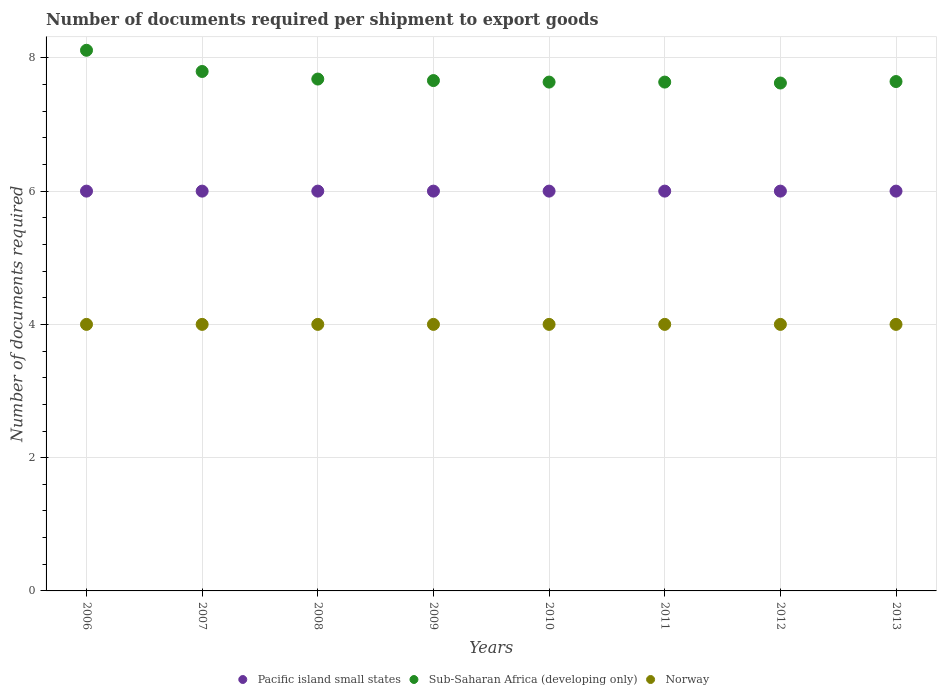How many different coloured dotlines are there?
Give a very brief answer. 3. What is the number of documents required per shipment to export goods in Norway in 2009?
Provide a short and direct response. 4. Across all years, what is the maximum number of documents required per shipment to export goods in Pacific island small states?
Provide a short and direct response. 6. In which year was the number of documents required per shipment to export goods in Sub-Saharan Africa (developing only) maximum?
Make the answer very short. 2006. In which year was the number of documents required per shipment to export goods in Sub-Saharan Africa (developing only) minimum?
Ensure brevity in your answer.  2012. What is the total number of documents required per shipment to export goods in Norway in the graph?
Offer a very short reply. 32. What is the difference between the number of documents required per shipment to export goods in Sub-Saharan Africa (developing only) in 2009 and the number of documents required per shipment to export goods in Pacific island small states in 2012?
Your answer should be very brief. 1.66. What is the average number of documents required per shipment to export goods in Sub-Saharan Africa (developing only) per year?
Give a very brief answer. 7.72. In the year 2008, what is the difference between the number of documents required per shipment to export goods in Pacific island small states and number of documents required per shipment to export goods in Sub-Saharan Africa (developing only)?
Provide a short and direct response. -1.68. In how many years, is the number of documents required per shipment to export goods in Pacific island small states greater than 6?
Give a very brief answer. 0. What is the difference between the highest and the lowest number of documents required per shipment to export goods in Sub-Saharan Africa (developing only)?
Your response must be concise. 0.49. In how many years, is the number of documents required per shipment to export goods in Pacific island small states greater than the average number of documents required per shipment to export goods in Pacific island small states taken over all years?
Keep it short and to the point. 0. Is the sum of the number of documents required per shipment to export goods in Sub-Saharan Africa (developing only) in 2011 and 2013 greater than the maximum number of documents required per shipment to export goods in Pacific island small states across all years?
Keep it short and to the point. Yes. Is the number of documents required per shipment to export goods in Sub-Saharan Africa (developing only) strictly greater than the number of documents required per shipment to export goods in Norway over the years?
Your response must be concise. Yes. How many years are there in the graph?
Keep it short and to the point. 8. Does the graph contain any zero values?
Your answer should be very brief. No. Does the graph contain grids?
Offer a very short reply. Yes. Where does the legend appear in the graph?
Offer a terse response. Bottom center. How many legend labels are there?
Provide a short and direct response. 3. What is the title of the graph?
Your answer should be very brief. Number of documents required per shipment to export goods. Does "Europe(developing only)" appear as one of the legend labels in the graph?
Provide a short and direct response. No. What is the label or title of the X-axis?
Offer a very short reply. Years. What is the label or title of the Y-axis?
Your answer should be very brief. Number of documents required. What is the Number of documents required in Pacific island small states in 2006?
Provide a succinct answer. 6. What is the Number of documents required of Sub-Saharan Africa (developing only) in 2006?
Make the answer very short. 8.11. What is the Number of documents required in Norway in 2006?
Offer a terse response. 4. What is the Number of documents required of Sub-Saharan Africa (developing only) in 2007?
Provide a succinct answer. 7.8. What is the Number of documents required in Norway in 2007?
Make the answer very short. 4. What is the Number of documents required in Pacific island small states in 2008?
Keep it short and to the point. 6. What is the Number of documents required of Sub-Saharan Africa (developing only) in 2008?
Give a very brief answer. 7.68. What is the Number of documents required in Pacific island small states in 2009?
Provide a succinct answer. 6. What is the Number of documents required of Sub-Saharan Africa (developing only) in 2009?
Your answer should be very brief. 7.66. What is the Number of documents required in Norway in 2009?
Your answer should be compact. 4. What is the Number of documents required in Sub-Saharan Africa (developing only) in 2010?
Make the answer very short. 7.64. What is the Number of documents required in Norway in 2010?
Make the answer very short. 4. What is the Number of documents required of Pacific island small states in 2011?
Your answer should be compact. 6. What is the Number of documents required of Sub-Saharan Africa (developing only) in 2011?
Give a very brief answer. 7.64. What is the Number of documents required of Sub-Saharan Africa (developing only) in 2012?
Offer a very short reply. 7.62. What is the Number of documents required in Norway in 2012?
Offer a terse response. 4. What is the Number of documents required of Pacific island small states in 2013?
Keep it short and to the point. 6. What is the Number of documents required of Sub-Saharan Africa (developing only) in 2013?
Provide a succinct answer. 7.64. What is the Number of documents required in Norway in 2013?
Your answer should be very brief. 4. Across all years, what is the maximum Number of documents required in Pacific island small states?
Offer a very short reply. 6. Across all years, what is the maximum Number of documents required in Sub-Saharan Africa (developing only)?
Offer a terse response. 8.11. Across all years, what is the maximum Number of documents required of Norway?
Give a very brief answer. 4. Across all years, what is the minimum Number of documents required of Pacific island small states?
Your answer should be very brief. 6. Across all years, what is the minimum Number of documents required of Sub-Saharan Africa (developing only)?
Offer a very short reply. 7.62. Across all years, what is the minimum Number of documents required of Norway?
Provide a short and direct response. 4. What is the total Number of documents required of Pacific island small states in the graph?
Keep it short and to the point. 48. What is the total Number of documents required of Sub-Saharan Africa (developing only) in the graph?
Provide a short and direct response. 61.79. What is the total Number of documents required of Norway in the graph?
Give a very brief answer. 32. What is the difference between the Number of documents required in Sub-Saharan Africa (developing only) in 2006 and that in 2007?
Your answer should be very brief. 0.32. What is the difference between the Number of documents required in Sub-Saharan Africa (developing only) in 2006 and that in 2008?
Ensure brevity in your answer.  0.43. What is the difference between the Number of documents required in Norway in 2006 and that in 2008?
Keep it short and to the point. 0. What is the difference between the Number of documents required of Sub-Saharan Africa (developing only) in 2006 and that in 2009?
Your answer should be very brief. 0.45. What is the difference between the Number of documents required in Norway in 2006 and that in 2009?
Offer a very short reply. 0. What is the difference between the Number of documents required in Sub-Saharan Africa (developing only) in 2006 and that in 2010?
Ensure brevity in your answer.  0.48. What is the difference between the Number of documents required in Sub-Saharan Africa (developing only) in 2006 and that in 2011?
Offer a terse response. 0.48. What is the difference between the Number of documents required of Norway in 2006 and that in 2011?
Keep it short and to the point. 0. What is the difference between the Number of documents required of Sub-Saharan Africa (developing only) in 2006 and that in 2012?
Give a very brief answer. 0.49. What is the difference between the Number of documents required of Norway in 2006 and that in 2012?
Provide a short and direct response. 0. What is the difference between the Number of documents required of Sub-Saharan Africa (developing only) in 2006 and that in 2013?
Keep it short and to the point. 0.47. What is the difference between the Number of documents required of Norway in 2006 and that in 2013?
Ensure brevity in your answer.  0. What is the difference between the Number of documents required of Pacific island small states in 2007 and that in 2008?
Give a very brief answer. 0. What is the difference between the Number of documents required of Sub-Saharan Africa (developing only) in 2007 and that in 2008?
Keep it short and to the point. 0.11. What is the difference between the Number of documents required in Pacific island small states in 2007 and that in 2009?
Keep it short and to the point. 0. What is the difference between the Number of documents required in Sub-Saharan Africa (developing only) in 2007 and that in 2009?
Offer a very short reply. 0.14. What is the difference between the Number of documents required in Sub-Saharan Africa (developing only) in 2007 and that in 2010?
Provide a succinct answer. 0.16. What is the difference between the Number of documents required of Sub-Saharan Africa (developing only) in 2007 and that in 2011?
Offer a terse response. 0.16. What is the difference between the Number of documents required of Pacific island small states in 2007 and that in 2012?
Your answer should be very brief. 0. What is the difference between the Number of documents required in Sub-Saharan Africa (developing only) in 2007 and that in 2012?
Offer a very short reply. 0.17. What is the difference between the Number of documents required of Norway in 2007 and that in 2012?
Provide a succinct answer. 0. What is the difference between the Number of documents required in Pacific island small states in 2007 and that in 2013?
Make the answer very short. 0. What is the difference between the Number of documents required in Sub-Saharan Africa (developing only) in 2007 and that in 2013?
Your response must be concise. 0.15. What is the difference between the Number of documents required of Norway in 2007 and that in 2013?
Offer a terse response. 0. What is the difference between the Number of documents required in Pacific island small states in 2008 and that in 2009?
Your response must be concise. 0. What is the difference between the Number of documents required of Sub-Saharan Africa (developing only) in 2008 and that in 2009?
Give a very brief answer. 0.02. What is the difference between the Number of documents required in Sub-Saharan Africa (developing only) in 2008 and that in 2010?
Provide a short and direct response. 0.05. What is the difference between the Number of documents required of Sub-Saharan Africa (developing only) in 2008 and that in 2011?
Offer a terse response. 0.05. What is the difference between the Number of documents required of Pacific island small states in 2008 and that in 2012?
Your response must be concise. 0. What is the difference between the Number of documents required of Sub-Saharan Africa (developing only) in 2008 and that in 2012?
Keep it short and to the point. 0.06. What is the difference between the Number of documents required in Norway in 2008 and that in 2012?
Your answer should be compact. 0. What is the difference between the Number of documents required of Pacific island small states in 2008 and that in 2013?
Ensure brevity in your answer.  0. What is the difference between the Number of documents required of Sub-Saharan Africa (developing only) in 2008 and that in 2013?
Give a very brief answer. 0.04. What is the difference between the Number of documents required of Pacific island small states in 2009 and that in 2010?
Ensure brevity in your answer.  0. What is the difference between the Number of documents required of Sub-Saharan Africa (developing only) in 2009 and that in 2010?
Offer a very short reply. 0.02. What is the difference between the Number of documents required of Norway in 2009 and that in 2010?
Offer a terse response. 0. What is the difference between the Number of documents required in Sub-Saharan Africa (developing only) in 2009 and that in 2011?
Make the answer very short. 0.02. What is the difference between the Number of documents required in Sub-Saharan Africa (developing only) in 2009 and that in 2012?
Your response must be concise. 0.04. What is the difference between the Number of documents required in Pacific island small states in 2009 and that in 2013?
Your answer should be compact. 0. What is the difference between the Number of documents required of Sub-Saharan Africa (developing only) in 2009 and that in 2013?
Ensure brevity in your answer.  0.01. What is the difference between the Number of documents required in Norway in 2009 and that in 2013?
Keep it short and to the point. 0. What is the difference between the Number of documents required in Pacific island small states in 2010 and that in 2011?
Make the answer very short. 0. What is the difference between the Number of documents required in Sub-Saharan Africa (developing only) in 2010 and that in 2012?
Your response must be concise. 0.01. What is the difference between the Number of documents required of Norway in 2010 and that in 2012?
Make the answer very short. 0. What is the difference between the Number of documents required of Sub-Saharan Africa (developing only) in 2010 and that in 2013?
Ensure brevity in your answer.  -0.01. What is the difference between the Number of documents required in Pacific island small states in 2011 and that in 2012?
Your answer should be compact. 0. What is the difference between the Number of documents required in Sub-Saharan Africa (developing only) in 2011 and that in 2012?
Provide a short and direct response. 0.01. What is the difference between the Number of documents required of Pacific island small states in 2011 and that in 2013?
Your response must be concise. 0. What is the difference between the Number of documents required of Sub-Saharan Africa (developing only) in 2011 and that in 2013?
Provide a short and direct response. -0.01. What is the difference between the Number of documents required of Sub-Saharan Africa (developing only) in 2012 and that in 2013?
Offer a terse response. -0.02. What is the difference between the Number of documents required of Pacific island small states in 2006 and the Number of documents required of Sub-Saharan Africa (developing only) in 2007?
Your answer should be compact. -1.8. What is the difference between the Number of documents required of Sub-Saharan Africa (developing only) in 2006 and the Number of documents required of Norway in 2007?
Your answer should be compact. 4.11. What is the difference between the Number of documents required in Pacific island small states in 2006 and the Number of documents required in Sub-Saharan Africa (developing only) in 2008?
Offer a very short reply. -1.68. What is the difference between the Number of documents required of Pacific island small states in 2006 and the Number of documents required of Norway in 2008?
Keep it short and to the point. 2. What is the difference between the Number of documents required of Sub-Saharan Africa (developing only) in 2006 and the Number of documents required of Norway in 2008?
Give a very brief answer. 4.11. What is the difference between the Number of documents required of Pacific island small states in 2006 and the Number of documents required of Sub-Saharan Africa (developing only) in 2009?
Offer a terse response. -1.66. What is the difference between the Number of documents required of Sub-Saharan Africa (developing only) in 2006 and the Number of documents required of Norway in 2009?
Give a very brief answer. 4.11. What is the difference between the Number of documents required in Pacific island small states in 2006 and the Number of documents required in Sub-Saharan Africa (developing only) in 2010?
Offer a very short reply. -1.64. What is the difference between the Number of documents required in Pacific island small states in 2006 and the Number of documents required in Norway in 2010?
Ensure brevity in your answer.  2. What is the difference between the Number of documents required of Sub-Saharan Africa (developing only) in 2006 and the Number of documents required of Norway in 2010?
Your answer should be compact. 4.11. What is the difference between the Number of documents required in Pacific island small states in 2006 and the Number of documents required in Sub-Saharan Africa (developing only) in 2011?
Offer a very short reply. -1.64. What is the difference between the Number of documents required of Sub-Saharan Africa (developing only) in 2006 and the Number of documents required of Norway in 2011?
Make the answer very short. 4.11. What is the difference between the Number of documents required of Pacific island small states in 2006 and the Number of documents required of Sub-Saharan Africa (developing only) in 2012?
Provide a short and direct response. -1.62. What is the difference between the Number of documents required of Sub-Saharan Africa (developing only) in 2006 and the Number of documents required of Norway in 2012?
Provide a succinct answer. 4.11. What is the difference between the Number of documents required of Pacific island small states in 2006 and the Number of documents required of Sub-Saharan Africa (developing only) in 2013?
Keep it short and to the point. -1.64. What is the difference between the Number of documents required in Pacific island small states in 2006 and the Number of documents required in Norway in 2013?
Your response must be concise. 2. What is the difference between the Number of documents required in Sub-Saharan Africa (developing only) in 2006 and the Number of documents required in Norway in 2013?
Provide a short and direct response. 4.11. What is the difference between the Number of documents required of Pacific island small states in 2007 and the Number of documents required of Sub-Saharan Africa (developing only) in 2008?
Make the answer very short. -1.68. What is the difference between the Number of documents required in Sub-Saharan Africa (developing only) in 2007 and the Number of documents required in Norway in 2008?
Ensure brevity in your answer.  3.8. What is the difference between the Number of documents required of Pacific island small states in 2007 and the Number of documents required of Sub-Saharan Africa (developing only) in 2009?
Offer a terse response. -1.66. What is the difference between the Number of documents required of Sub-Saharan Africa (developing only) in 2007 and the Number of documents required of Norway in 2009?
Keep it short and to the point. 3.8. What is the difference between the Number of documents required in Pacific island small states in 2007 and the Number of documents required in Sub-Saharan Africa (developing only) in 2010?
Your answer should be very brief. -1.64. What is the difference between the Number of documents required in Pacific island small states in 2007 and the Number of documents required in Norway in 2010?
Make the answer very short. 2. What is the difference between the Number of documents required of Sub-Saharan Africa (developing only) in 2007 and the Number of documents required of Norway in 2010?
Your answer should be compact. 3.8. What is the difference between the Number of documents required in Pacific island small states in 2007 and the Number of documents required in Sub-Saharan Africa (developing only) in 2011?
Your response must be concise. -1.64. What is the difference between the Number of documents required of Pacific island small states in 2007 and the Number of documents required of Norway in 2011?
Provide a succinct answer. 2. What is the difference between the Number of documents required of Sub-Saharan Africa (developing only) in 2007 and the Number of documents required of Norway in 2011?
Provide a short and direct response. 3.8. What is the difference between the Number of documents required in Pacific island small states in 2007 and the Number of documents required in Sub-Saharan Africa (developing only) in 2012?
Keep it short and to the point. -1.62. What is the difference between the Number of documents required of Pacific island small states in 2007 and the Number of documents required of Norway in 2012?
Offer a very short reply. 2. What is the difference between the Number of documents required in Sub-Saharan Africa (developing only) in 2007 and the Number of documents required in Norway in 2012?
Provide a succinct answer. 3.8. What is the difference between the Number of documents required of Pacific island small states in 2007 and the Number of documents required of Sub-Saharan Africa (developing only) in 2013?
Give a very brief answer. -1.64. What is the difference between the Number of documents required of Pacific island small states in 2007 and the Number of documents required of Norway in 2013?
Give a very brief answer. 2. What is the difference between the Number of documents required of Sub-Saharan Africa (developing only) in 2007 and the Number of documents required of Norway in 2013?
Provide a short and direct response. 3.8. What is the difference between the Number of documents required of Pacific island small states in 2008 and the Number of documents required of Sub-Saharan Africa (developing only) in 2009?
Your answer should be very brief. -1.66. What is the difference between the Number of documents required in Pacific island small states in 2008 and the Number of documents required in Norway in 2009?
Give a very brief answer. 2. What is the difference between the Number of documents required in Sub-Saharan Africa (developing only) in 2008 and the Number of documents required in Norway in 2009?
Provide a succinct answer. 3.68. What is the difference between the Number of documents required in Pacific island small states in 2008 and the Number of documents required in Sub-Saharan Africa (developing only) in 2010?
Offer a very short reply. -1.64. What is the difference between the Number of documents required of Pacific island small states in 2008 and the Number of documents required of Norway in 2010?
Ensure brevity in your answer.  2. What is the difference between the Number of documents required of Sub-Saharan Africa (developing only) in 2008 and the Number of documents required of Norway in 2010?
Keep it short and to the point. 3.68. What is the difference between the Number of documents required in Pacific island small states in 2008 and the Number of documents required in Sub-Saharan Africa (developing only) in 2011?
Your answer should be compact. -1.64. What is the difference between the Number of documents required of Sub-Saharan Africa (developing only) in 2008 and the Number of documents required of Norway in 2011?
Keep it short and to the point. 3.68. What is the difference between the Number of documents required in Pacific island small states in 2008 and the Number of documents required in Sub-Saharan Africa (developing only) in 2012?
Offer a very short reply. -1.62. What is the difference between the Number of documents required of Sub-Saharan Africa (developing only) in 2008 and the Number of documents required of Norway in 2012?
Provide a short and direct response. 3.68. What is the difference between the Number of documents required of Pacific island small states in 2008 and the Number of documents required of Sub-Saharan Africa (developing only) in 2013?
Make the answer very short. -1.64. What is the difference between the Number of documents required in Sub-Saharan Africa (developing only) in 2008 and the Number of documents required in Norway in 2013?
Your answer should be compact. 3.68. What is the difference between the Number of documents required in Pacific island small states in 2009 and the Number of documents required in Sub-Saharan Africa (developing only) in 2010?
Offer a very short reply. -1.64. What is the difference between the Number of documents required of Pacific island small states in 2009 and the Number of documents required of Norway in 2010?
Your answer should be compact. 2. What is the difference between the Number of documents required in Sub-Saharan Africa (developing only) in 2009 and the Number of documents required in Norway in 2010?
Make the answer very short. 3.66. What is the difference between the Number of documents required in Pacific island small states in 2009 and the Number of documents required in Sub-Saharan Africa (developing only) in 2011?
Your answer should be very brief. -1.64. What is the difference between the Number of documents required of Pacific island small states in 2009 and the Number of documents required of Norway in 2011?
Give a very brief answer. 2. What is the difference between the Number of documents required of Sub-Saharan Africa (developing only) in 2009 and the Number of documents required of Norway in 2011?
Offer a very short reply. 3.66. What is the difference between the Number of documents required of Pacific island small states in 2009 and the Number of documents required of Sub-Saharan Africa (developing only) in 2012?
Provide a succinct answer. -1.62. What is the difference between the Number of documents required in Sub-Saharan Africa (developing only) in 2009 and the Number of documents required in Norway in 2012?
Offer a terse response. 3.66. What is the difference between the Number of documents required of Pacific island small states in 2009 and the Number of documents required of Sub-Saharan Africa (developing only) in 2013?
Offer a very short reply. -1.64. What is the difference between the Number of documents required in Pacific island small states in 2009 and the Number of documents required in Norway in 2013?
Ensure brevity in your answer.  2. What is the difference between the Number of documents required of Sub-Saharan Africa (developing only) in 2009 and the Number of documents required of Norway in 2013?
Offer a very short reply. 3.66. What is the difference between the Number of documents required of Pacific island small states in 2010 and the Number of documents required of Sub-Saharan Africa (developing only) in 2011?
Your answer should be compact. -1.64. What is the difference between the Number of documents required of Sub-Saharan Africa (developing only) in 2010 and the Number of documents required of Norway in 2011?
Your response must be concise. 3.64. What is the difference between the Number of documents required of Pacific island small states in 2010 and the Number of documents required of Sub-Saharan Africa (developing only) in 2012?
Make the answer very short. -1.62. What is the difference between the Number of documents required of Pacific island small states in 2010 and the Number of documents required of Norway in 2012?
Your answer should be compact. 2. What is the difference between the Number of documents required in Sub-Saharan Africa (developing only) in 2010 and the Number of documents required in Norway in 2012?
Ensure brevity in your answer.  3.64. What is the difference between the Number of documents required in Pacific island small states in 2010 and the Number of documents required in Sub-Saharan Africa (developing only) in 2013?
Your response must be concise. -1.64. What is the difference between the Number of documents required in Pacific island small states in 2010 and the Number of documents required in Norway in 2013?
Your response must be concise. 2. What is the difference between the Number of documents required in Sub-Saharan Africa (developing only) in 2010 and the Number of documents required in Norway in 2013?
Your answer should be compact. 3.64. What is the difference between the Number of documents required of Pacific island small states in 2011 and the Number of documents required of Sub-Saharan Africa (developing only) in 2012?
Offer a terse response. -1.62. What is the difference between the Number of documents required in Sub-Saharan Africa (developing only) in 2011 and the Number of documents required in Norway in 2012?
Keep it short and to the point. 3.64. What is the difference between the Number of documents required of Pacific island small states in 2011 and the Number of documents required of Sub-Saharan Africa (developing only) in 2013?
Your answer should be very brief. -1.64. What is the difference between the Number of documents required in Sub-Saharan Africa (developing only) in 2011 and the Number of documents required in Norway in 2013?
Offer a very short reply. 3.64. What is the difference between the Number of documents required in Pacific island small states in 2012 and the Number of documents required in Sub-Saharan Africa (developing only) in 2013?
Your response must be concise. -1.64. What is the difference between the Number of documents required of Pacific island small states in 2012 and the Number of documents required of Norway in 2013?
Your response must be concise. 2. What is the difference between the Number of documents required in Sub-Saharan Africa (developing only) in 2012 and the Number of documents required in Norway in 2013?
Provide a short and direct response. 3.62. What is the average Number of documents required of Pacific island small states per year?
Ensure brevity in your answer.  6. What is the average Number of documents required of Sub-Saharan Africa (developing only) per year?
Your response must be concise. 7.72. What is the average Number of documents required in Norway per year?
Provide a succinct answer. 4. In the year 2006, what is the difference between the Number of documents required of Pacific island small states and Number of documents required of Sub-Saharan Africa (developing only)?
Provide a succinct answer. -2.11. In the year 2006, what is the difference between the Number of documents required in Sub-Saharan Africa (developing only) and Number of documents required in Norway?
Your answer should be very brief. 4.11. In the year 2007, what is the difference between the Number of documents required in Pacific island small states and Number of documents required in Sub-Saharan Africa (developing only)?
Provide a succinct answer. -1.8. In the year 2007, what is the difference between the Number of documents required in Pacific island small states and Number of documents required in Norway?
Provide a short and direct response. 2. In the year 2007, what is the difference between the Number of documents required of Sub-Saharan Africa (developing only) and Number of documents required of Norway?
Ensure brevity in your answer.  3.8. In the year 2008, what is the difference between the Number of documents required of Pacific island small states and Number of documents required of Sub-Saharan Africa (developing only)?
Give a very brief answer. -1.68. In the year 2008, what is the difference between the Number of documents required of Sub-Saharan Africa (developing only) and Number of documents required of Norway?
Give a very brief answer. 3.68. In the year 2009, what is the difference between the Number of documents required in Pacific island small states and Number of documents required in Sub-Saharan Africa (developing only)?
Give a very brief answer. -1.66. In the year 2009, what is the difference between the Number of documents required in Pacific island small states and Number of documents required in Norway?
Ensure brevity in your answer.  2. In the year 2009, what is the difference between the Number of documents required in Sub-Saharan Africa (developing only) and Number of documents required in Norway?
Provide a short and direct response. 3.66. In the year 2010, what is the difference between the Number of documents required in Pacific island small states and Number of documents required in Sub-Saharan Africa (developing only)?
Your answer should be very brief. -1.64. In the year 2010, what is the difference between the Number of documents required in Pacific island small states and Number of documents required in Norway?
Your response must be concise. 2. In the year 2010, what is the difference between the Number of documents required in Sub-Saharan Africa (developing only) and Number of documents required in Norway?
Ensure brevity in your answer.  3.64. In the year 2011, what is the difference between the Number of documents required in Pacific island small states and Number of documents required in Sub-Saharan Africa (developing only)?
Give a very brief answer. -1.64. In the year 2011, what is the difference between the Number of documents required in Pacific island small states and Number of documents required in Norway?
Your answer should be very brief. 2. In the year 2011, what is the difference between the Number of documents required of Sub-Saharan Africa (developing only) and Number of documents required of Norway?
Give a very brief answer. 3.64. In the year 2012, what is the difference between the Number of documents required of Pacific island small states and Number of documents required of Sub-Saharan Africa (developing only)?
Your answer should be compact. -1.62. In the year 2012, what is the difference between the Number of documents required of Pacific island small states and Number of documents required of Norway?
Offer a terse response. 2. In the year 2012, what is the difference between the Number of documents required in Sub-Saharan Africa (developing only) and Number of documents required in Norway?
Provide a succinct answer. 3.62. In the year 2013, what is the difference between the Number of documents required of Pacific island small states and Number of documents required of Sub-Saharan Africa (developing only)?
Offer a very short reply. -1.64. In the year 2013, what is the difference between the Number of documents required in Pacific island small states and Number of documents required in Norway?
Make the answer very short. 2. In the year 2013, what is the difference between the Number of documents required in Sub-Saharan Africa (developing only) and Number of documents required in Norway?
Keep it short and to the point. 3.64. What is the ratio of the Number of documents required of Pacific island small states in 2006 to that in 2007?
Offer a very short reply. 1. What is the ratio of the Number of documents required of Sub-Saharan Africa (developing only) in 2006 to that in 2007?
Keep it short and to the point. 1.04. What is the ratio of the Number of documents required of Pacific island small states in 2006 to that in 2008?
Your response must be concise. 1. What is the ratio of the Number of documents required of Sub-Saharan Africa (developing only) in 2006 to that in 2008?
Provide a short and direct response. 1.06. What is the ratio of the Number of documents required in Pacific island small states in 2006 to that in 2009?
Give a very brief answer. 1. What is the ratio of the Number of documents required of Sub-Saharan Africa (developing only) in 2006 to that in 2009?
Keep it short and to the point. 1.06. What is the ratio of the Number of documents required of Pacific island small states in 2006 to that in 2010?
Your answer should be very brief. 1. What is the ratio of the Number of documents required in Sub-Saharan Africa (developing only) in 2006 to that in 2010?
Provide a short and direct response. 1.06. What is the ratio of the Number of documents required of Norway in 2006 to that in 2010?
Offer a terse response. 1. What is the ratio of the Number of documents required of Pacific island small states in 2006 to that in 2011?
Provide a short and direct response. 1. What is the ratio of the Number of documents required of Sub-Saharan Africa (developing only) in 2006 to that in 2011?
Provide a succinct answer. 1.06. What is the ratio of the Number of documents required of Norway in 2006 to that in 2011?
Provide a short and direct response. 1. What is the ratio of the Number of documents required in Sub-Saharan Africa (developing only) in 2006 to that in 2012?
Provide a succinct answer. 1.06. What is the ratio of the Number of documents required of Norway in 2006 to that in 2012?
Offer a very short reply. 1. What is the ratio of the Number of documents required in Pacific island small states in 2006 to that in 2013?
Give a very brief answer. 1. What is the ratio of the Number of documents required in Sub-Saharan Africa (developing only) in 2006 to that in 2013?
Keep it short and to the point. 1.06. What is the ratio of the Number of documents required in Sub-Saharan Africa (developing only) in 2007 to that in 2008?
Provide a short and direct response. 1.01. What is the ratio of the Number of documents required of Norway in 2007 to that in 2008?
Your response must be concise. 1. What is the ratio of the Number of documents required in Sub-Saharan Africa (developing only) in 2007 to that in 2009?
Offer a terse response. 1.02. What is the ratio of the Number of documents required in Norway in 2007 to that in 2009?
Offer a terse response. 1. What is the ratio of the Number of documents required of Pacific island small states in 2007 to that in 2010?
Give a very brief answer. 1. What is the ratio of the Number of documents required in Sub-Saharan Africa (developing only) in 2007 to that in 2010?
Provide a succinct answer. 1.02. What is the ratio of the Number of documents required of Pacific island small states in 2007 to that in 2011?
Ensure brevity in your answer.  1. What is the ratio of the Number of documents required of Sub-Saharan Africa (developing only) in 2007 to that in 2011?
Your answer should be very brief. 1.02. What is the ratio of the Number of documents required in Pacific island small states in 2007 to that in 2012?
Offer a very short reply. 1. What is the ratio of the Number of documents required of Sub-Saharan Africa (developing only) in 2007 to that in 2012?
Your answer should be very brief. 1.02. What is the ratio of the Number of documents required in Sub-Saharan Africa (developing only) in 2007 to that in 2013?
Make the answer very short. 1.02. What is the ratio of the Number of documents required in Pacific island small states in 2008 to that in 2009?
Your answer should be very brief. 1. What is the ratio of the Number of documents required of Sub-Saharan Africa (developing only) in 2008 to that in 2009?
Offer a terse response. 1. What is the ratio of the Number of documents required in Norway in 2008 to that in 2009?
Ensure brevity in your answer.  1. What is the ratio of the Number of documents required in Sub-Saharan Africa (developing only) in 2008 to that in 2010?
Your answer should be compact. 1.01. What is the ratio of the Number of documents required in Pacific island small states in 2008 to that in 2011?
Provide a short and direct response. 1. What is the ratio of the Number of documents required in Sub-Saharan Africa (developing only) in 2008 to that in 2011?
Provide a short and direct response. 1.01. What is the ratio of the Number of documents required in Norway in 2008 to that in 2012?
Ensure brevity in your answer.  1. What is the ratio of the Number of documents required of Pacific island small states in 2009 to that in 2010?
Your answer should be compact. 1. What is the ratio of the Number of documents required of Sub-Saharan Africa (developing only) in 2009 to that in 2010?
Your answer should be compact. 1. What is the ratio of the Number of documents required in Norway in 2009 to that in 2010?
Provide a short and direct response. 1. What is the ratio of the Number of documents required of Sub-Saharan Africa (developing only) in 2009 to that in 2011?
Your answer should be compact. 1. What is the ratio of the Number of documents required in Sub-Saharan Africa (developing only) in 2009 to that in 2012?
Your response must be concise. 1. What is the ratio of the Number of documents required of Norway in 2009 to that in 2013?
Offer a terse response. 1. What is the ratio of the Number of documents required in Pacific island small states in 2010 to that in 2011?
Your response must be concise. 1. What is the ratio of the Number of documents required in Sub-Saharan Africa (developing only) in 2010 to that in 2011?
Provide a succinct answer. 1. What is the ratio of the Number of documents required in Norway in 2010 to that in 2011?
Offer a very short reply. 1. What is the ratio of the Number of documents required of Norway in 2010 to that in 2012?
Ensure brevity in your answer.  1. What is the ratio of the Number of documents required of Pacific island small states in 2010 to that in 2013?
Keep it short and to the point. 1. What is the ratio of the Number of documents required of Sub-Saharan Africa (developing only) in 2010 to that in 2013?
Your answer should be compact. 1. What is the ratio of the Number of documents required of Norway in 2010 to that in 2013?
Your answer should be compact. 1. What is the ratio of the Number of documents required of Norway in 2011 to that in 2012?
Your response must be concise. 1. What is the ratio of the Number of documents required in Pacific island small states in 2011 to that in 2013?
Your response must be concise. 1. What is the ratio of the Number of documents required of Sub-Saharan Africa (developing only) in 2012 to that in 2013?
Your answer should be compact. 1. What is the difference between the highest and the second highest Number of documents required in Sub-Saharan Africa (developing only)?
Your answer should be very brief. 0.32. What is the difference between the highest and the second highest Number of documents required in Norway?
Your answer should be very brief. 0. What is the difference between the highest and the lowest Number of documents required of Pacific island small states?
Offer a terse response. 0. What is the difference between the highest and the lowest Number of documents required in Sub-Saharan Africa (developing only)?
Your answer should be compact. 0.49. 